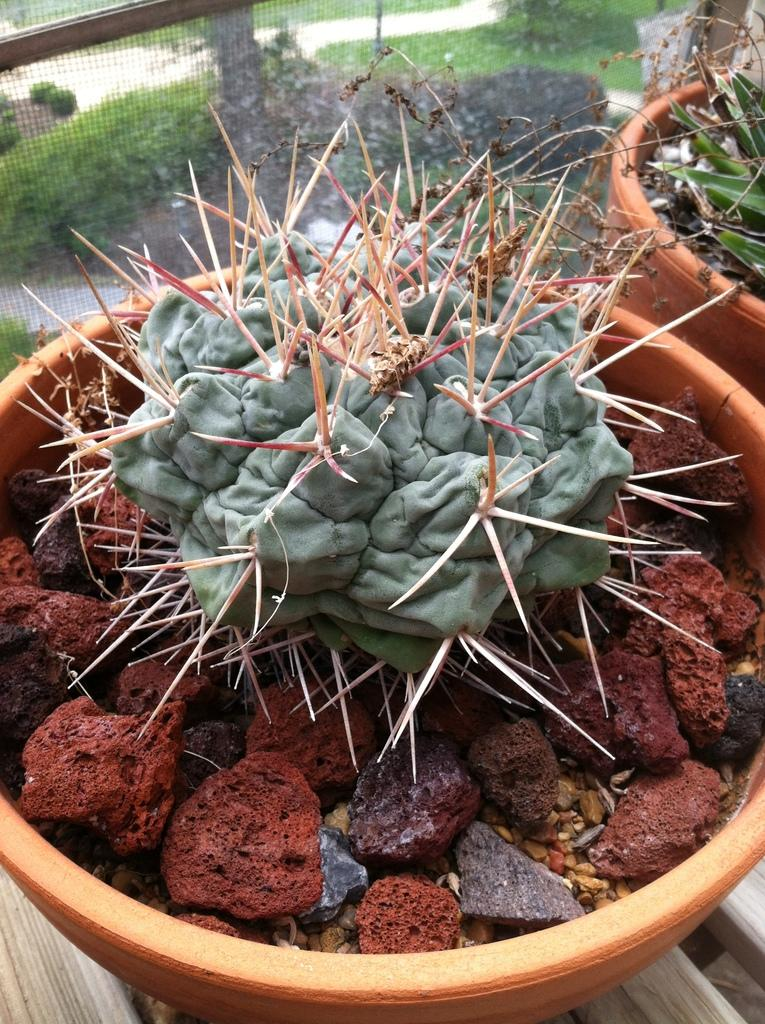How many potted plants are visible in the image? There are two potted plants in the image. What can be seen in the background of the image? In the background of the image, there is a fence, plants, and stones. Can you describe the fence in the image? The fence is visible in the background of the image. What type of heart can be seen beating in the image? There is no heart visible in the image. 